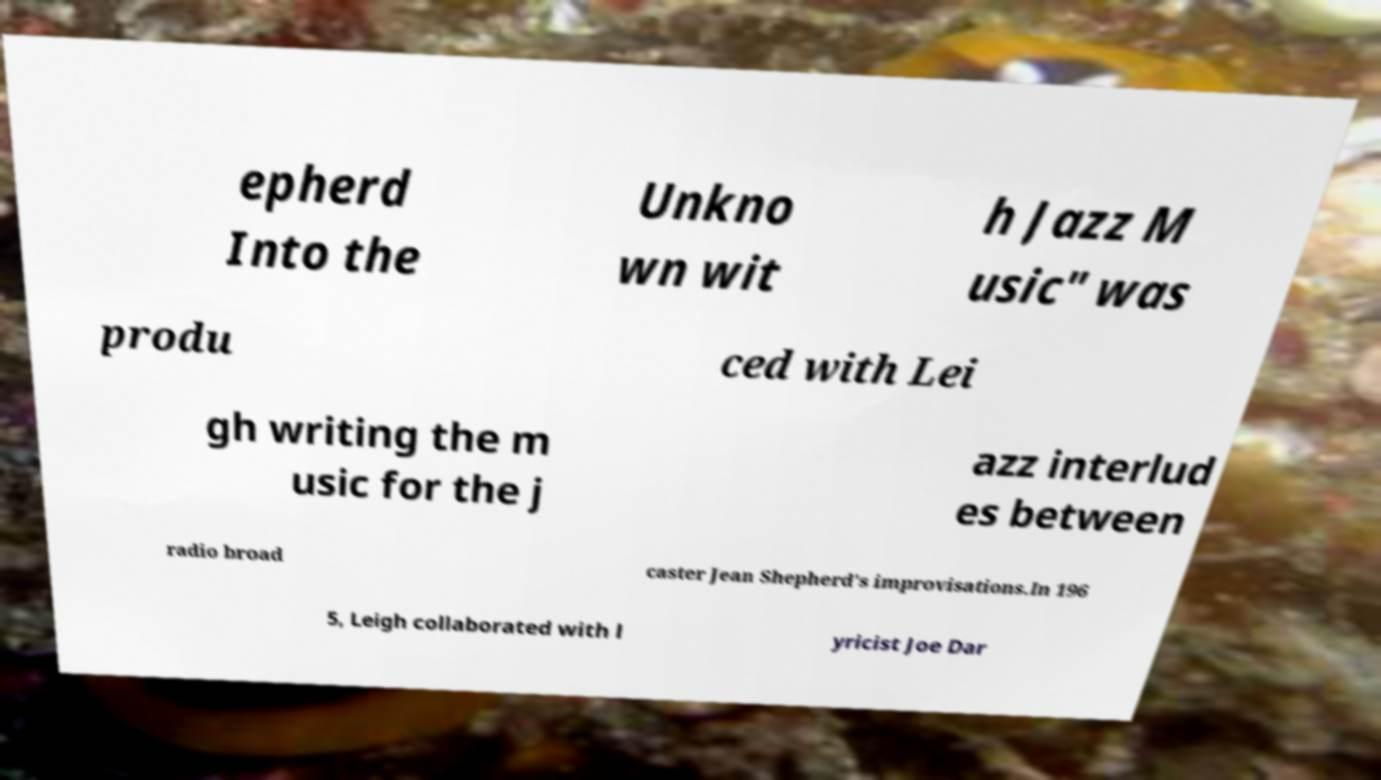Please read and relay the text visible in this image. What does it say? epherd Into the Unkno wn wit h Jazz M usic" was produ ced with Lei gh writing the m usic for the j azz interlud es between radio broad caster Jean Shepherd's improvisations.In 196 5, Leigh collaborated with l yricist Joe Dar 